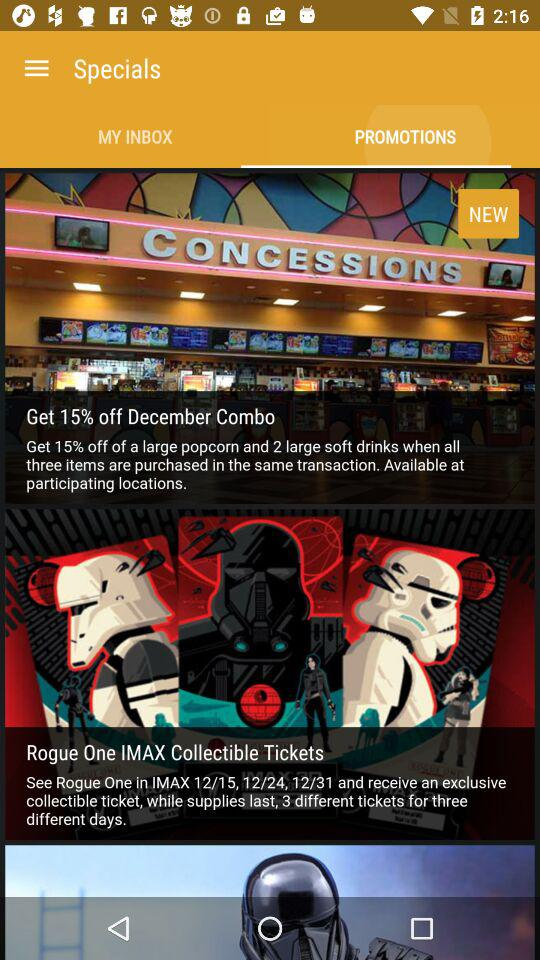On which date are Rogue One IMAX collectible tickets available?
When the provided information is insufficient, respond with <no answer>. <no answer> 